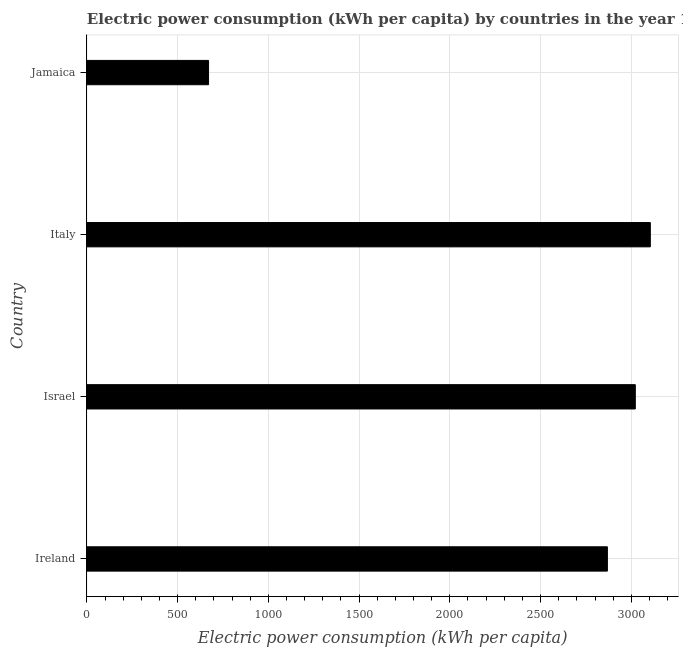What is the title of the graph?
Your answer should be very brief. Electric power consumption (kWh per capita) by countries in the year 1980. What is the label or title of the X-axis?
Provide a short and direct response. Electric power consumption (kWh per capita). What is the label or title of the Y-axis?
Your answer should be very brief. Country. What is the electric power consumption in Ireland?
Ensure brevity in your answer.  2868.32. Across all countries, what is the maximum electric power consumption?
Provide a succinct answer. 3104.85. Across all countries, what is the minimum electric power consumption?
Offer a terse response. 670.42. In which country was the electric power consumption minimum?
Provide a short and direct response. Jamaica. What is the sum of the electric power consumption?
Your response must be concise. 9665.77. What is the difference between the electric power consumption in Ireland and Israel?
Offer a very short reply. -153.86. What is the average electric power consumption per country?
Keep it short and to the point. 2416.44. What is the median electric power consumption?
Ensure brevity in your answer.  2945.25. What is the ratio of the electric power consumption in Ireland to that in Italy?
Make the answer very short. 0.92. Is the difference between the electric power consumption in Israel and Italy greater than the difference between any two countries?
Offer a terse response. No. What is the difference between the highest and the second highest electric power consumption?
Provide a short and direct response. 82.68. Is the sum of the electric power consumption in Italy and Jamaica greater than the maximum electric power consumption across all countries?
Make the answer very short. Yes. What is the difference between the highest and the lowest electric power consumption?
Your answer should be very brief. 2434.44. In how many countries, is the electric power consumption greater than the average electric power consumption taken over all countries?
Give a very brief answer. 3. How many bars are there?
Keep it short and to the point. 4. Are all the bars in the graph horizontal?
Make the answer very short. Yes. What is the difference between two consecutive major ticks on the X-axis?
Your response must be concise. 500. Are the values on the major ticks of X-axis written in scientific E-notation?
Provide a succinct answer. No. What is the Electric power consumption (kWh per capita) in Ireland?
Ensure brevity in your answer.  2868.32. What is the Electric power consumption (kWh per capita) in Israel?
Your response must be concise. 3022.18. What is the Electric power consumption (kWh per capita) in Italy?
Your response must be concise. 3104.85. What is the Electric power consumption (kWh per capita) of Jamaica?
Give a very brief answer. 670.42. What is the difference between the Electric power consumption (kWh per capita) in Ireland and Israel?
Offer a very short reply. -153.86. What is the difference between the Electric power consumption (kWh per capita) in Ireland and Italy?
Provide a short and direct response. -236.54. What is the difference between the Electric power consumption (kWh per capita) in Ireland and Jamaica?
Provide a short and direct response. 2197.9. What is the difference between the Electric power consumption (kWh per capita) in Israel and Italy?
Provide a short and direct response. -82.68. What is the difference between the Electric power consumption (kWh per capita) in Israel and Jamaica?
Offer a terse response. 2351.76. What is the difference between the Electric power consumption (kWh per capita) in Italy and Jamaica?
Your response must be concise. 2434.44. What is the ratio of the Electric power consumption (kWh per capita) in Ireland to that in Israel?
Give a very brief answer. 0.95. What is the ratio of the Electric power consumption (kWh per capita) in Ireland to that in Italy?
Provide a succinct answer. 0.92. What is the ratio of the Electric power consumption (kWh per capita) in Ireland to that in Jamaica?
Your response must be concise. 4.28. What is the ratio of the Electric power consumption (kWh per capita) in Israel to that in Jamaica?
Ensure brevity in your answer.  4.51. What is the ratio of the Electric power consumption (kWh per capita) in Italy to that in Jamaica?
Your response must be concise. 4.63. 